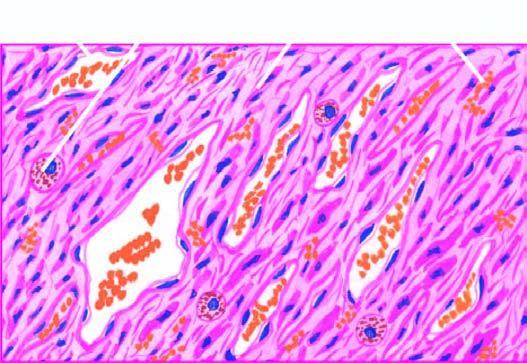when is kaposi's sarcoma?
Answer the question using a single word or phrase. In late nodular stage 